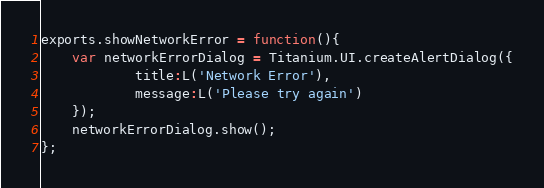Convert code to text. <code><loc_0><loc_0><loc_500><loc_500><_JavaScript_>exports.showNetworkError = function(){
	var networkErrorDialog = Titanium.UI.createAlertDialog({
			title:L('Network Error'),
			message:L('Please try again')
	});
	networkErrorDialog.show();
};

</code> 